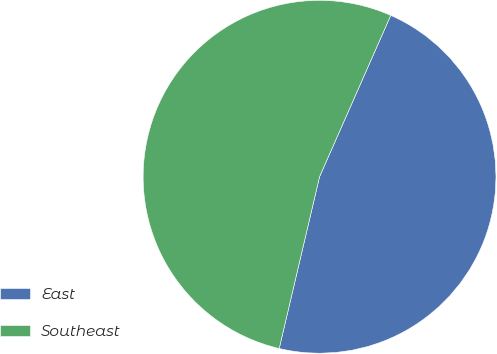Convert chart to OTSL. <chart><loc_0><loc_0><loc_500><loc_500><pie_chart><fcel>East<fcel>Southeast<nl><fcel>47.06%<fcel>52.94%<nl></chart> 